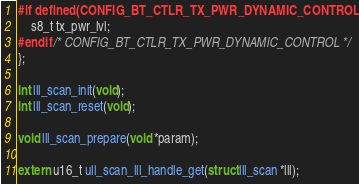Convert code to text. <code><loc_0><loc_0><loc_500><loc_500><_C_>#if defined(CONFIG_BT_CTLR_TX_PWR_DYNAMIC_CONTROL)
	s8_t tx_pwr_lvl;
#endif /* CONFIG_BT_CTLR_TX_PWR_DYNAMIC_CONTROL */
};

int lll_scan_init(void);
int lll_scan_reset(void);

void lll_scan_prepare(void *param);

extern u16_t ull_scan_lll_handle_get(struct lll_scan *lll);
</code> 